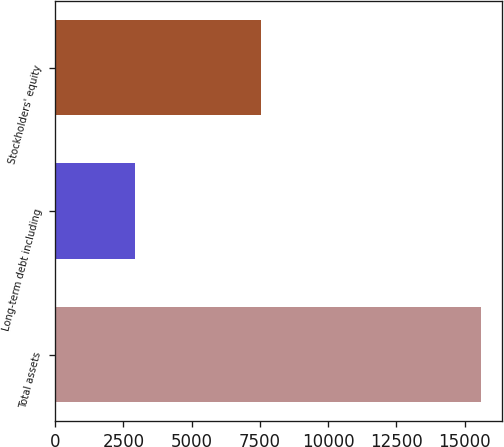<chart> <loc_0><loc_0><loc_500><loc_500><bar_chart><fcel>Total assets<fcel>Long-term debt including<fcel>Stockholders' equity<nl><fcel>15598<fcel>2938<fcel>7548<nl></chart> 